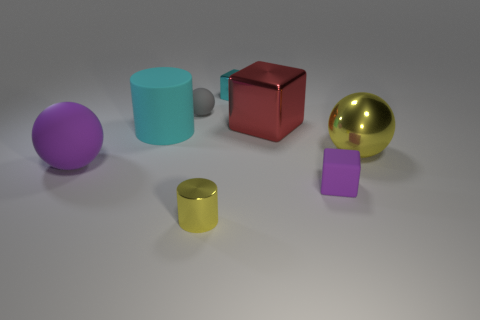What number of tiny purple matte things are the same shape as the red object?
Ensure brevity in your answer.  1. Are there any other things that have the same size as the cyan block?
Provide a short and direct response. Yes. There is a matte sphere to the right of the purple thing left of the small metal cylinder; what is its size?
Make the answer very short. Small. What number of things are either green shiny balls or objects behind the large rubber cylinder?
Make the answer very short. 3. Is the shape of the small rubber object that is left of the yellow cylinder the same as  the large purple matte object?
Provide a succinct answer. Yes. How many large metallic cubes are to the right of the yellow object that is to the left of the cyan metallic block that is on the right side of the gray object?
Offer a very short reply. 1. Is there any other thing that has the same shape as the large yellow thing?
Your answer should be compact. Yes. How many objects are either large yellow shiny balls or green rubber cubes?
Your response must be concise. 1. There is a small gray object; does it have the same shape as the cyan rubber object in front of the big cube?
Give a very brief answer. No. What shape is the purple matte object that is on the left side of the gray ball?
Make the answer very short. Sphere. 